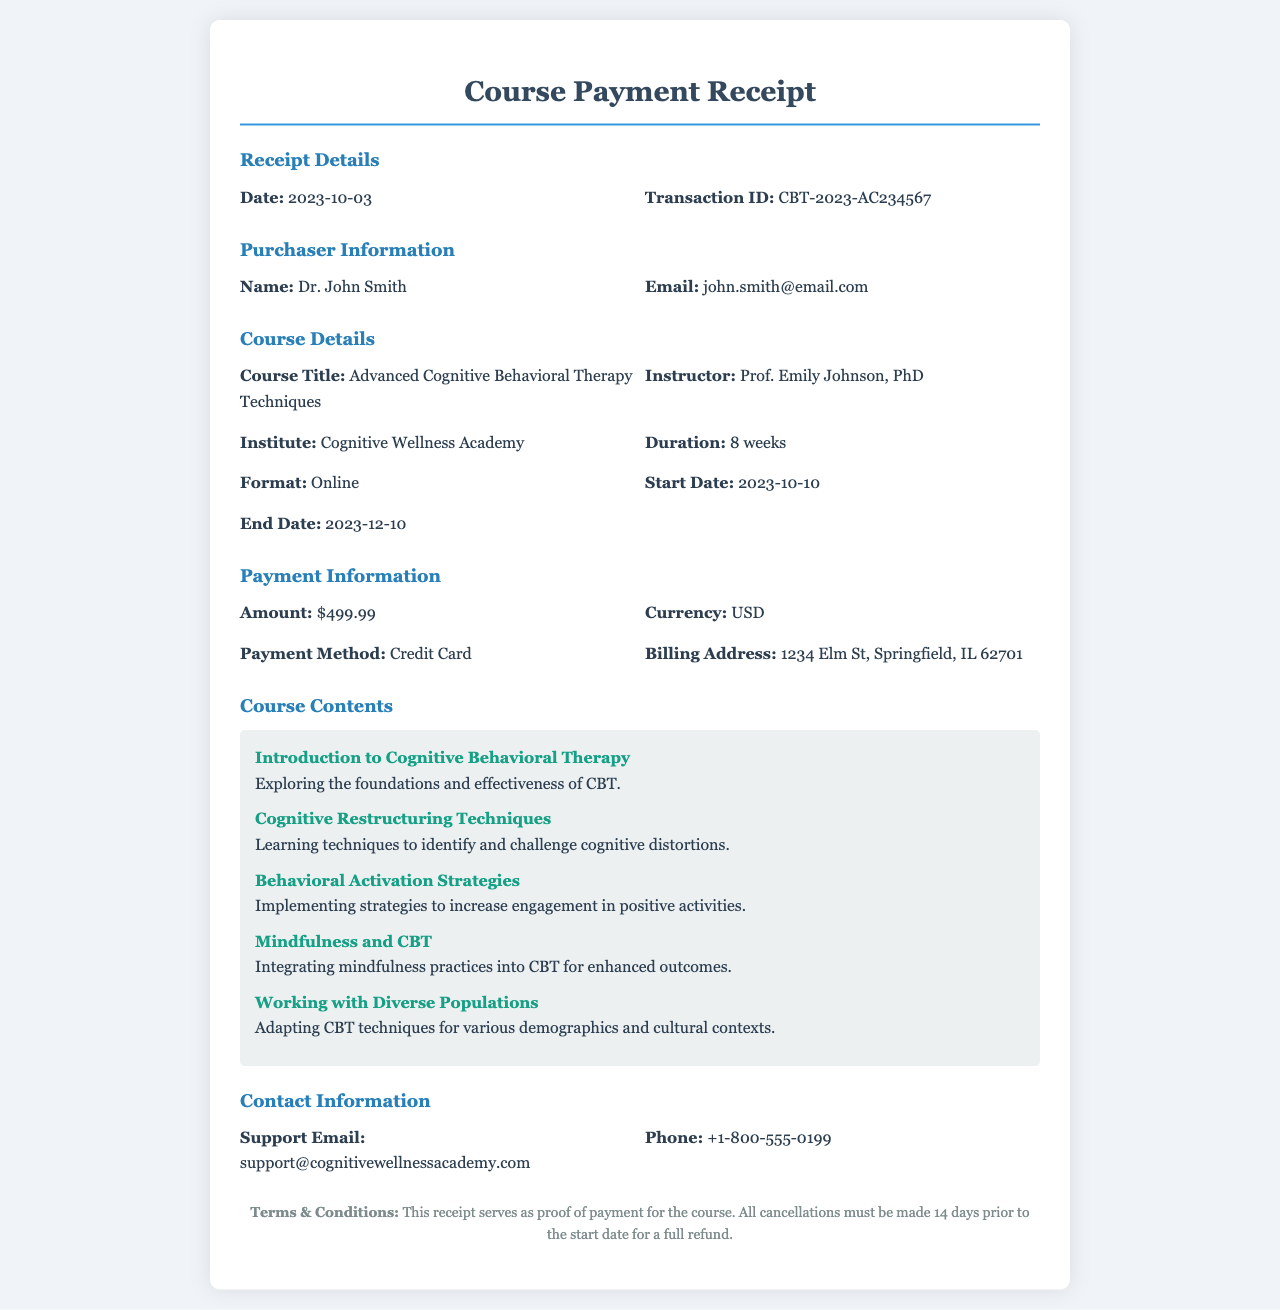What is the date of the receipt? The date of the receipt is explicitly stated in the document under "Receipt Details."
Answer: 2023-10-03 Who is the instructor for the course? The instructor's name is provided in the "Course Details" section of the document.
Answer: Prof. Emily Johnson, PhD What is the total amount paid for the course? The total amount is mentioned under "Payment Information" in the document.
Answer: $499.99 What payment method was used? The payment method is indicated in the "Payment Information" section.
Answer: Credit Card How many weeks is the course duration? The duration of the course is listed in the "Course Details" section.
Answer: 8 weeks What is the start date of the course? The start date is specifically stated in the "Course Details" section of the document.
Answer: 2023-10-10 What is the course title? The course title can be found in the "Course Details" section.
Answer: Advanced Cognitive Behavioral Therapy Techniques Where should support inquiries be directed? The support email address is provided in the "Contact Information" section.
Answer: support@cognitivewellnessacademy.com What must be done for a full refund? The conditions for a full refund are noted in the "Terms & Conditions" at the bottom of the document.
Answer: Cancellations must be made 14 days prior to the start date 